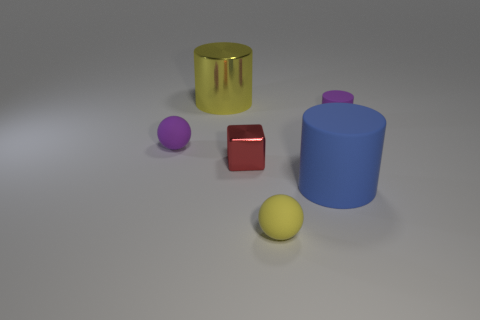There is a tiny rubber thing that is to the right of the red cube and on the left side of the small purple rubber cylinder; what shape is it?
Make the answer very short. Sphere. What number of things are either matte objects that are on the right side of the big matte cylinder or matte objects that are in front of the large blue thing?
Make the answer very short. 2. Are there an equal number of yellow metal objects in front of the small red block and metallic cubes behind the big shiny object?
Offer a terse response. Yes. What is the shape of the yellow thing that is in front of the small purple matte object in front of the tiny matte cylinder?
Keep it short and to the point. Sphere. Is there another large yellow thing of the same shape as the yellow rubber thing?
Ensure brevity in your answer.  No. How many yellow matte spheres are there?
Ensure brevity in your answer.  1. Is the large cylinder that is on the right side of the large metallic object made of the same material as the small red object?
Give a very brief answer. No. Is there a purple thing of the same size as the blue object?
Your answer should be compact. No. Is the shape of the red object the same as the purple object on the right side of the tiny red metal block?
Your answer should be compact. No. There is a tiny matte sphere to the left of the large object behind the tiny purple cylinder; are there any small purple matte objects that are behind it?
Make the answer very short. Yes. 